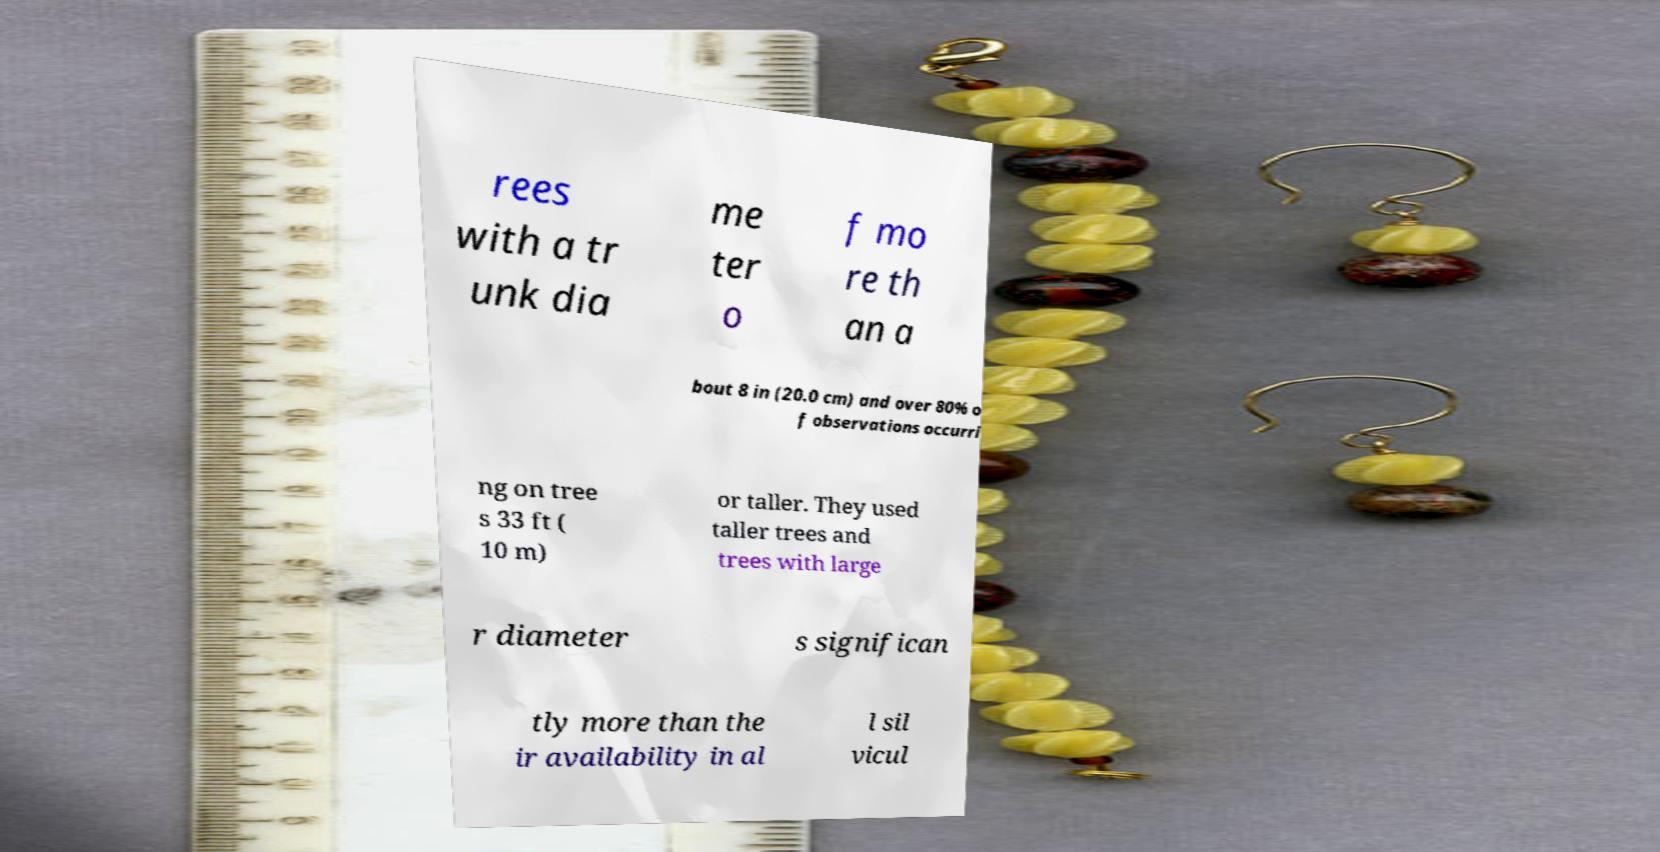There's text embedded in this image that I need extracted. Can you transcribe it verbatim? rees with a tr unk dia me ter o f mo re th an a bout 8 in (20.0 cm) and over 80% o f observations occurri ng on tree s 33 ft ( 10 m) or taller. They used taller trees and trees with large r diameter s significan tly more than the ir availability in al l sil vicul 